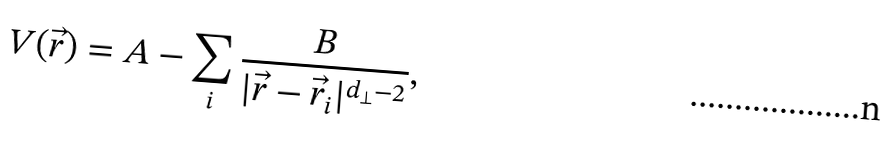<formula> <loc_0><loc_0><loc_500><loc_500>V ( \vec { r } ) = A - \sum _ { i } \frac { B } { | \vec { r } - \vec { r } _ { i } | ^ { d _ { \perp } - 2 } } ,</formula> 